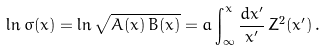Convert formula to latex. <formula><loc_0><loc_0><loc_500><loc_500>\ln { \sigma ( x ) } = \ln \sqrt { A ( x ) \, B ( x ) } = a \int ^ { x } _ { \infty } \frac { d x ^ { \prime } } { x ^ { \prime } } \, Z ^ { 2 } ( x ^ { \prime } ) \, .</formula> 